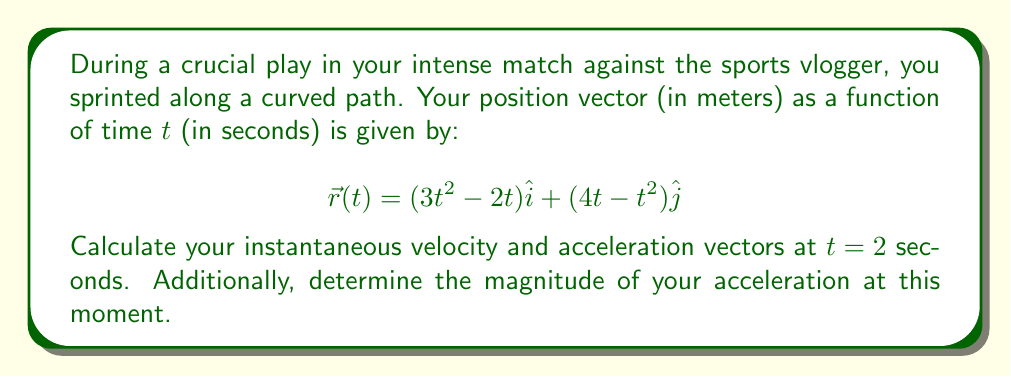Help me with this question. To solve this problem, we need to follow these steps:

1) First, let's find the velocity vector by differentiating the position vector with respect to time:

   $$\vec{v}(t) = \frac{d\vec{r}}{dt} = (6t - 2)\hat{i} + (4 - 2t)\hat{j}$$

2) Now, let's find the acceleration vector by differentiating the velocity vector:

   $$\vec{a}(t) = \frac{d\vec{v}}{dt} = 6\hat{i} - 2\hat{j}$$

3) To find the instantaneous velocity at t = 2 seconds, we substitute t = 2 into the velocity equation:

   $$\vec{v}(2) = (6(2) - 2)\hat{i} + (4 - 2(2))\hat{j} = 10\hat{i} + 0\hat{j} = 10\hat{i}$$

4) For the acceleration at t = 2 seconds, we don't need to substitute t because the acceleration is constant:

   $$\vec{a}(2) = 6\hat{i} - 2\hat{j}$$

5) To find the magnitude of the acceleration, we use the Pythagorean theorem:

   $$|\vec{a}| = \sqrt{6^2 + (-2)^2} = \sqrt{36 + 4} = \sqrt{40} = 2\sqrt{10}$$

Therefore, at t = 2 seconds:
- The instantaneous velocity vector is $10\hat{i}$ m/s
- The acceleration vector is $6\hat{i} - 2\hat{j}$ m/s²
- The magnitude of acceleration is $2\sqrt{10}$ m/s²
Answer: At t = 2 seconds:
Instantaneous velocity: $\vec{v}(2) = 10\hat{i}$ m/s
Acceleration: $\vec{a}(2) = 6\hat{i} - 2\hat{j}$ m/s²
Magnitude of acceleration: $|\vec{a}| = 2\sqrt{10}$ m/s² 